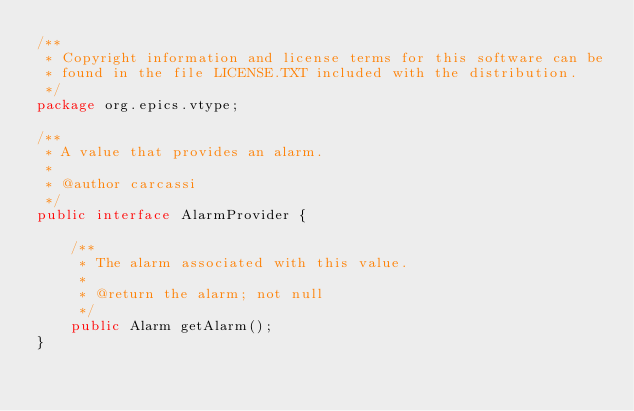<code> <loc_0><loc_0><loc_500><loc_500><_Java_>/**
 * Copyright information and license terms for this software can be
 * found in the file LICENSE.TXT included with the distribution.
 */
package org.epics.vtype;

/**
 * A value that provides an alarm.
 *
 * @author carcassi
 */
public interface AlarmProvider {
    
    /**
     * The alarm associated with this value.
     * 
     * @return the alarm; not null
     */
    public Alarm getAlarm();
}
</code> 